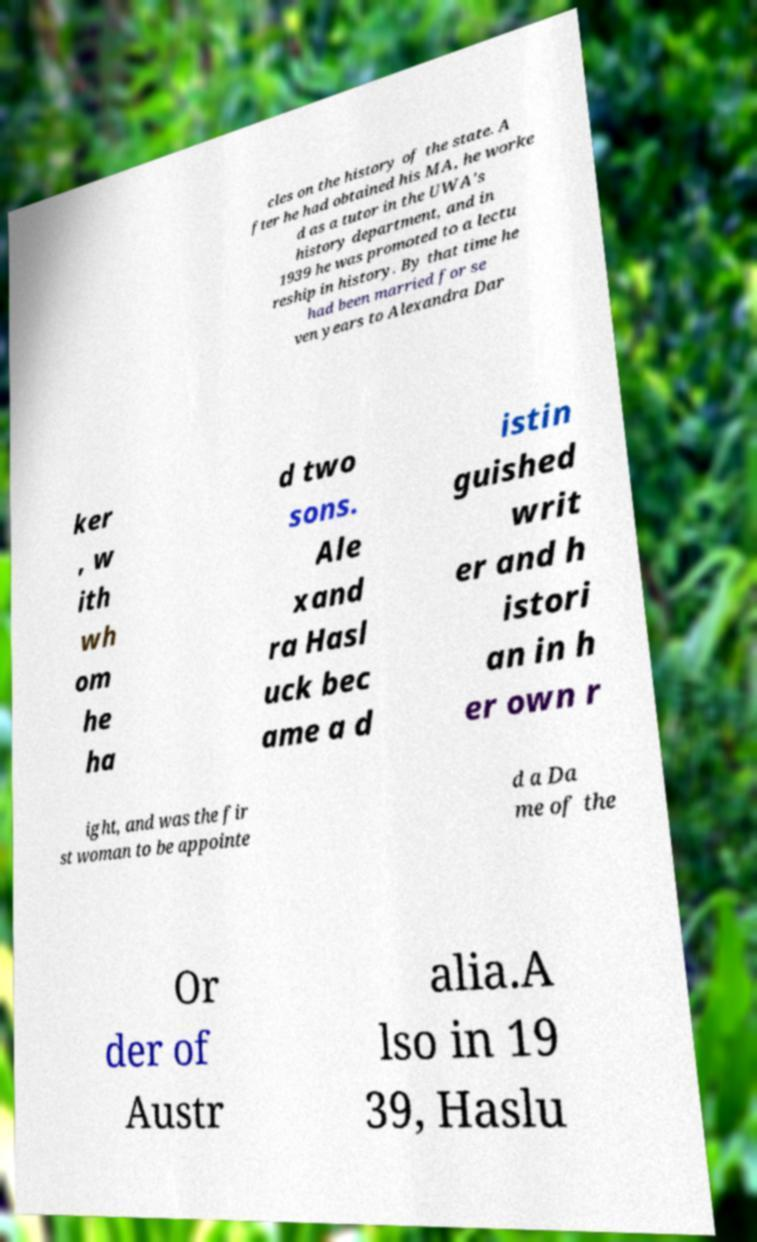There's text embedded in this image that I need extracted. Can you transcribe it verbatim? cles on the history of the state. A fter he had obtained his MA, he worke d as a tutor in the UWA's history department, and in 1939 he was promoted to a lectu reship in history. By that time he had been married for se ven years to Alexandra Dar ker , w ith wh om he ha d two sons. Ale xand ra Hasl uck bec ame a d istin guished writ er and h istori an in h er own r ight, and was the fir st woman to be appointe d a Da me of the Or der of Austr alia.A lso in 19 39, Haslu 